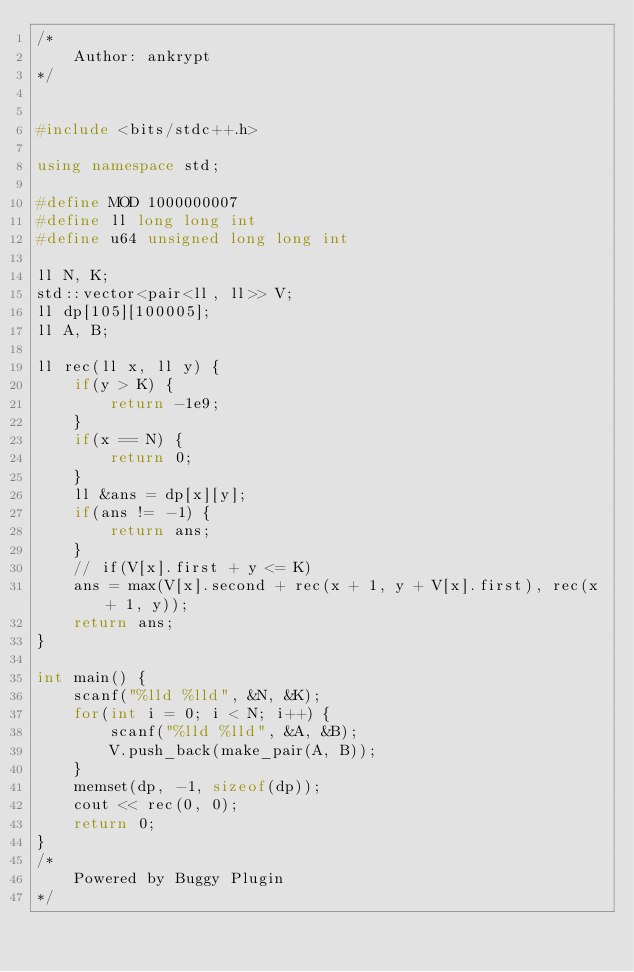<code> <loc_0><loc_0><loc_500><loc_500><_C++_>/* 
	Author: ankrypt
*/


#include <bits/stdc++.h>

using namespace std;

#define MOD 1000000007
#define ll long long int
#define u64 unsigned long long int

ll N, K;
std::vector<pair<ll, ll>> V;
ll dp[105][100005];
ll A, B;

ll rec(ll x, ll y) {
	if(y > K) {
		return -1e9;
	}
	if(x == N) {
		return 0;
	}
	ll &ans = dp[x][y];
	if(ans != -1) {
		return ans;
	}
	// if(V[x].first + y <= K)
	ans = max(V[x].second + rec(x + 1, y + V[x].first), rec(x + 1, y));
	return ans;
}

int main() {
	scanf("%lld %lld", &N, &K);
	for(int i = 0; i < N; i++) {
		scanf("%lld %lld", &A, &B);
		V.push_back(make_pair(A, B));
	}
	memset(dp, -1, sizeof(dp));
	cout << rec(0, 0);
	return 0;
}
/*
	Powered by Buggy Plugin
*/
</code> 